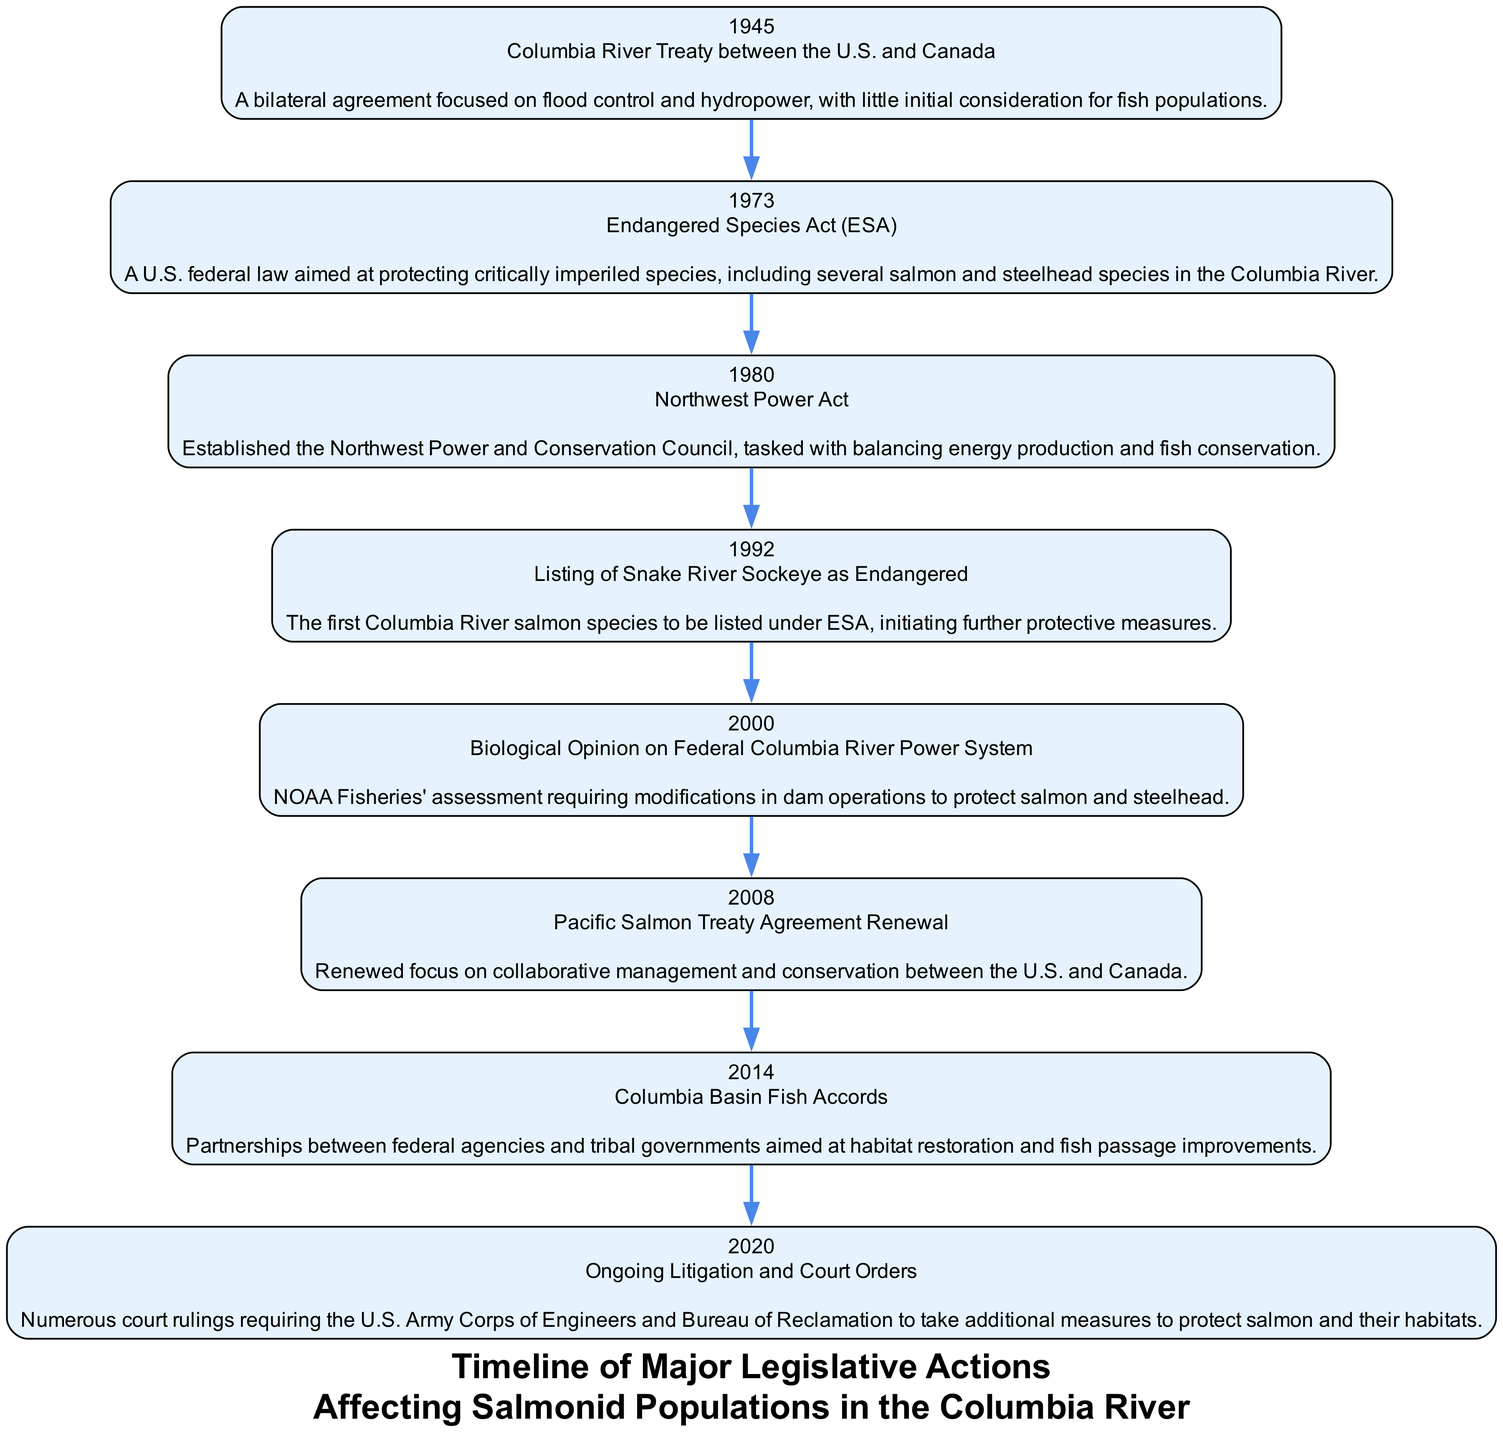What year was the Columbia River Treaty established? The Columbia River Treaty was established in 1945, as indicated by the first node in the diagram.
Answer: 1945 What major legislative action occurred in 1973? The major legislative action in 1973 was the Endangered Species Act (ESA), as shown in the second node.
Answer: Endangered Species Act (ESA) How many legislative actions are listed in total? The diagram contains a total of eight legislative actions, each represented by a different node along the timeline.
Answer: 8 What event in 2008 emphasizes collaboration between the U.S. and Canada? The 2008 Pacific Salmon Treaty Agreement Renewal is highlighted as it focuses on collaborative management and conservation efforts between the two countries.
Answer: Pacific Salmon Treaty Agreement Renewal Which event marks the first listing of a Columbia River salmon species under the Endangered Species Act? The listing of the Snake River Sockeye as Endangered in 1992 is the first instance noted in the diagram where a Columbia River salmon species received such protection under the ESA.
Answer: Listing of Snake River Sockeye as Endangered What does the Biological Opinion of 2000 require regarding dam operations? The Biological Opinion on the Federal Columbia River Power System from 2000 requires modifications in dam operations to protect salmon and steelhead populations, highlighting the importance of this legislation.
Answer: Modifications in dam operations How does the Northwest Power Act influence the management of salmon populations? The Northwest Power Act established the Northwest Power and Conservation Council, indicating that it plays a critical role in balancing energy production with fish conservation efforts.
Answer: Balancing energy production and fish conservation What is a significant outcome of the ongoing litigation reported in 2020? The ongoing litigation and court orders in 2020 resulted in numerous court rulings that mandated additional measures for the protection of salmon and their habitats, emphasizing legal accountability in conservation efforts.
Answer: Additional measures to protect salmon and their habitats 